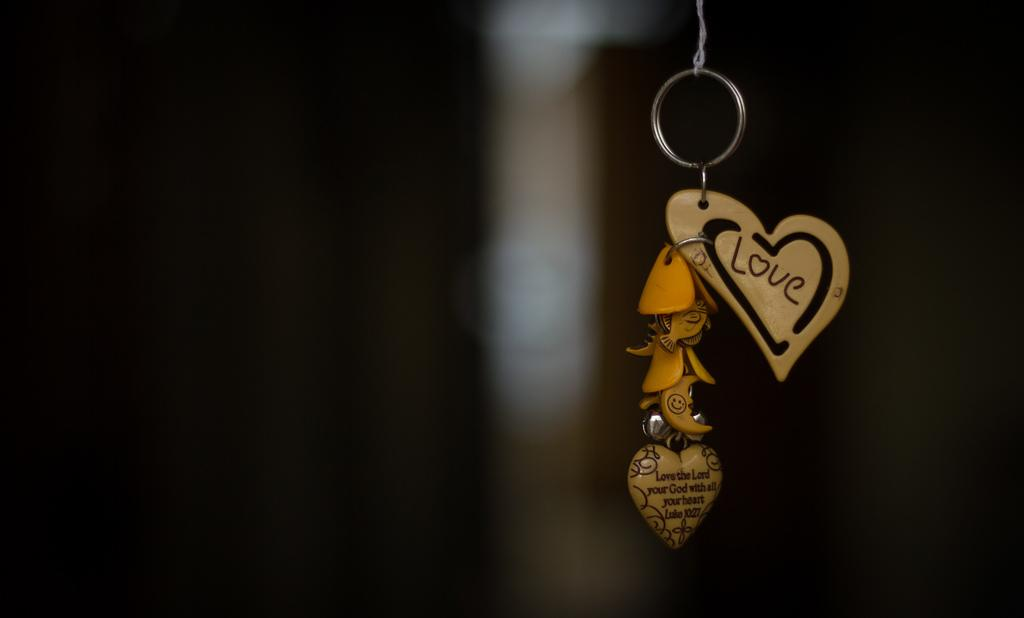What object is featured in the image? There is a keychain in the image. What shape is the keychain? The keychain is in the shape of a heart. What word is written on the keychain? The word "Love" is written on the keychain. What type of food is being served for dinner on the keychain? There is no food or dinner depicted on the keychain; it features the word "Love" written on a heart-shaped keychain. 